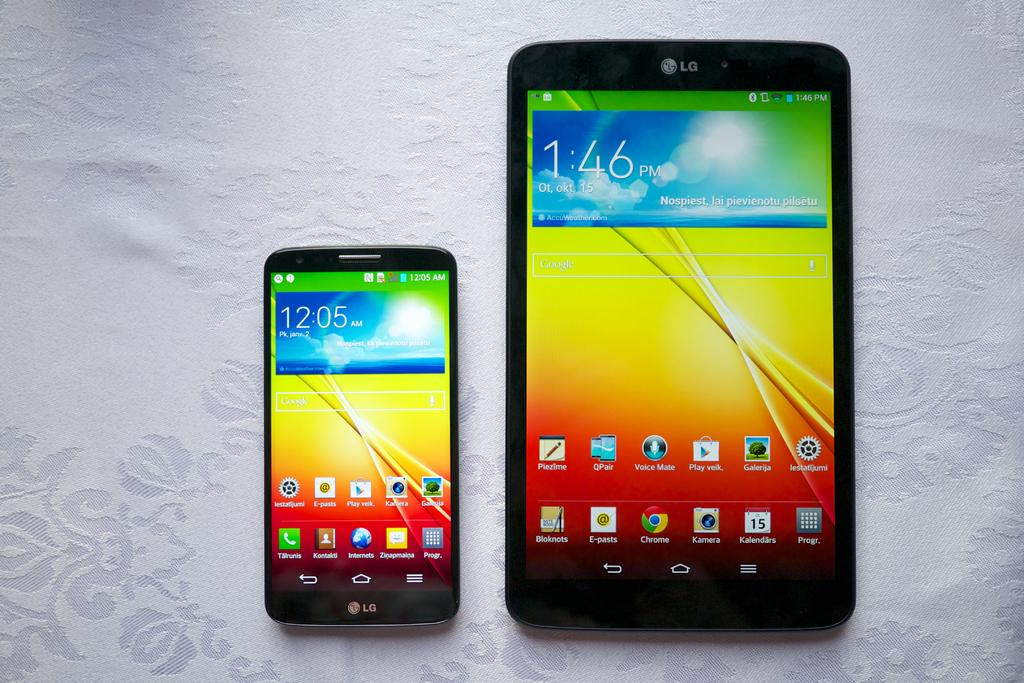How many mobiles can be seen in the image? There are two mobiles in the image. What is the color of the surface on which the mobiles are placed? The mobiles are on a white surface. What can be seen on the screens of the mobiles? There are icons visible on the mobiles. How many balls are resting on the mobiles in the image? There are no balls visible in the image; the mobiles are on a white surface with icons displayed on their screens. 